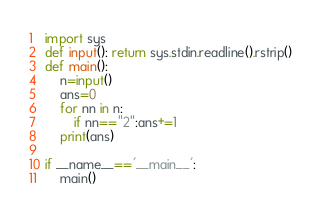<code> <loc_0><loc_0><loc_500><loc_500><_Python_>import sys
def input(): return sys.stdin.readline().rstrip()
def main():
    n=input()
    ans=0
    for nn in n:
        if nn=="2":ans+=1
    print(ans)

if __name__=='__main__':
    main()</code> 